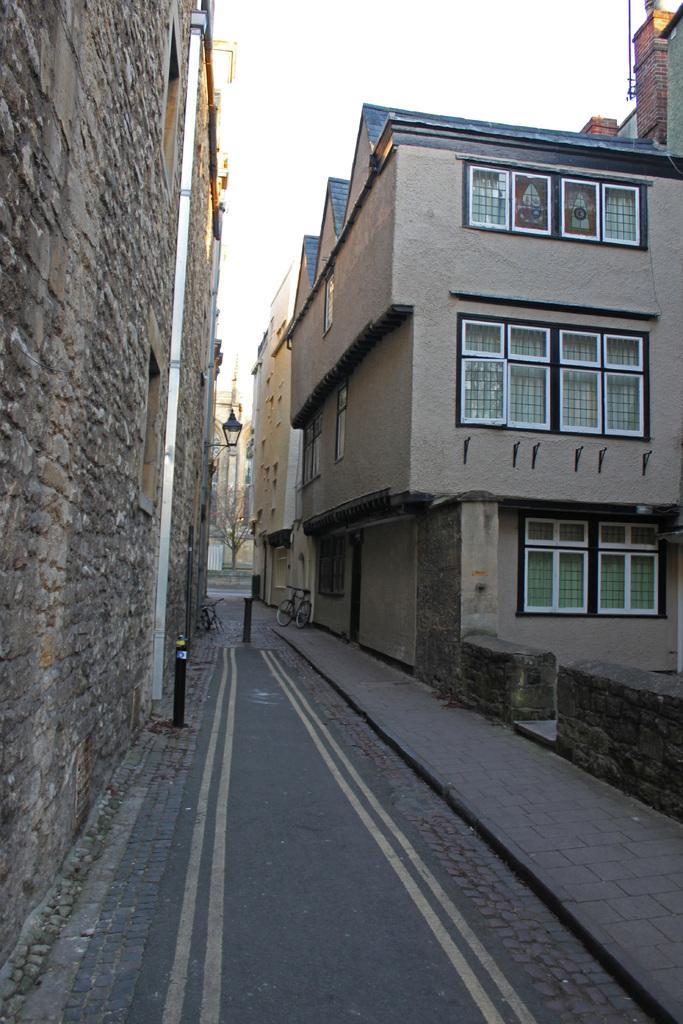Could you give a brief overview of what you see in this image? In this image we can see some buildings with windows and a bicycle parked aside. We can also see a pole beside a wall, a street lamp, the road, trees and the sky which looks cloudy. 